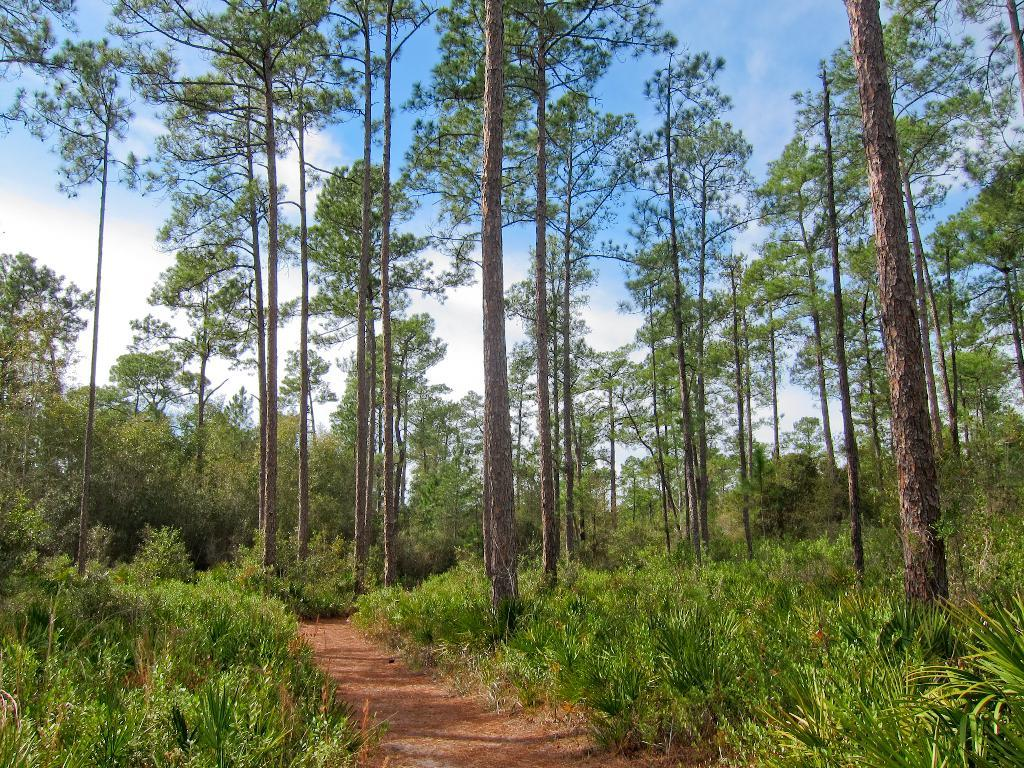What type of natural elements can be seen in the image? There are many trees and plants in the image. What kind of pathway is present in the image? There is a walkway in the image. What can be seen in the background of the image? The sky is visible in the background of the image. What type of chin can be seen on the tree in the image? There is no chin present in the image, as it features trees and plants in a natural setting. 